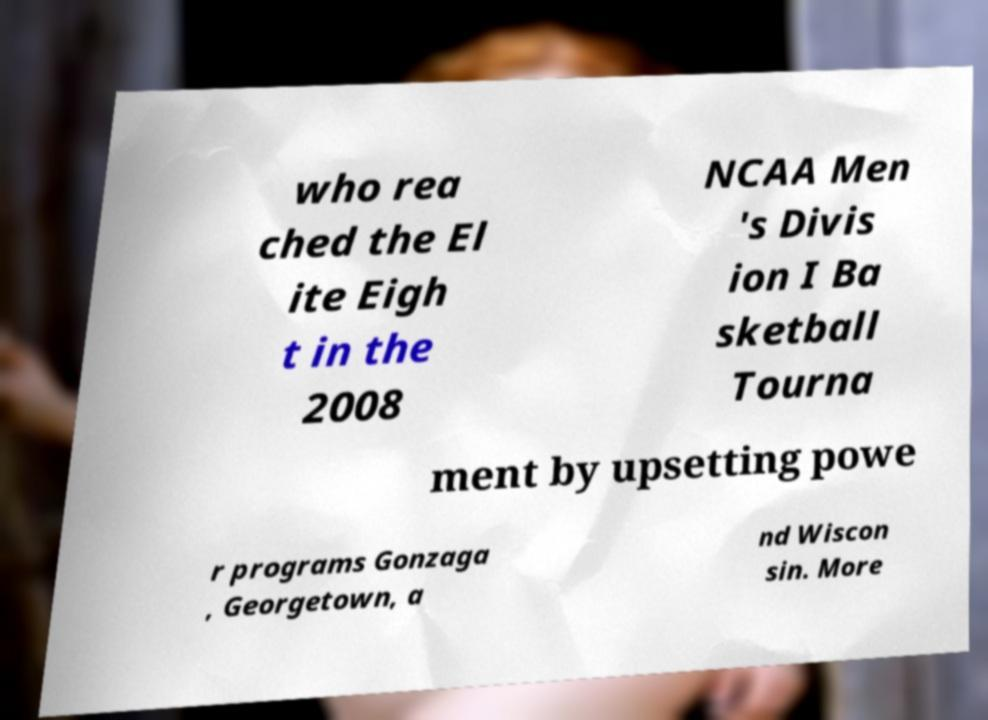Can you accurately transcribe the text from the provided image for me? who rea ched the El ite Eigh t in the 2008 NCAA Men 's Divis ion I Ba sketball Tourna ment by upsetting powe r programs Gonzaga , Georgetown, a nd Wiscon sin. More 